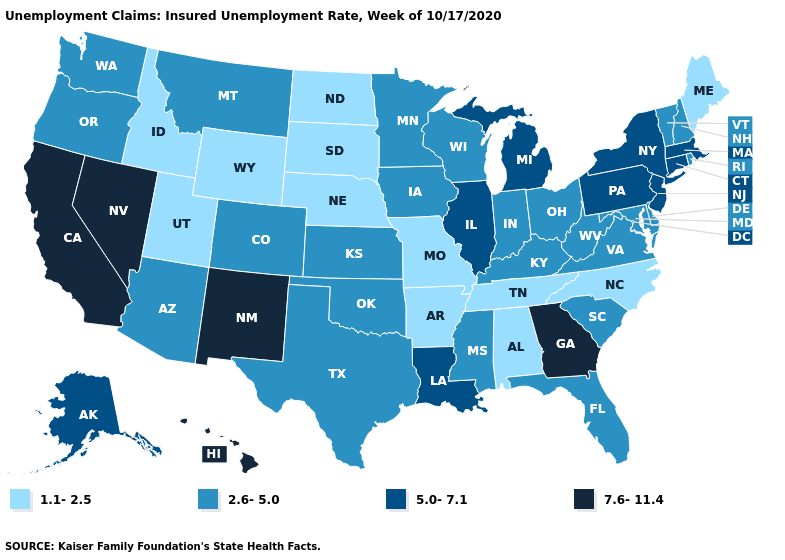What is the value of Maryland?
Write a very short answer. 2.6-5.0. What is the highest value in states that border Colorado?
Quick response, please. 7.6-11.4. What is the value of Wyoming?
Give a very brief answer. 1.1-2.5. Name the states that have a value in the range 2.6-5.0?
Be succinct. Arizona, Colorado, Delaware, Florida, Indiana, Iowa, Kansas, Kentucky, Maryland, Minnesota, Mississippi, Montana, New Hampshire, Ohio, Oklahoma, Oregon, Rhode Island, South Carolina, Texas, Vermont, Virginia, Washington, West Virginia, Wisconsin. Among the states that border Colorado , does Wyoming have the lowest value?
Answer briefly. Yes. What is the value of New Mexico?
Be succinct. 7.6-11.4. Does Kentucky have a higher value than Tennessee?
Keep it brief. Yes. Name the states that have a value in the range 2.6-5.0?
Quick response, please. Arizona, Colorado, Delaware, Florida, Indiana, Iowa, Kansas, Kentucky, Maryland, Minnesota, Mississippi, Montana, New Hampshire, Ohio, Oklahoma, Oregon, Rhode Island, South Carolina, Texas, Vermont, Virginia, Washington, West Virginia, Wisconsin. Name the states that have a value in the range 2.6-5.0?
Write a very short answer. Arizona, Colorado, Delaware, Florida, Indiana, Iowa, Kansas, Kentucky, Maryland, Minnesota, Mississippi, Montana, New Hampshire, Ohio, Oklahoma, Oregon, Rhode Island, South Carolina, Texas, Vermont, Virginia, Washington, West Virginia, Wisconsin. Does Michigan have a higher value than Georgia?
Short answer required. No. What is the lowest value in states that border South Dakota?
Short answer required. 1.1-2.5. What is the lowest value in the South?
Be succinct. 1.1-2.5. What is the highest value in states that border Pennsylvania?
Answer briefly. 5.0-7.1. What is the value of New Jersey?
Short answer required. 5.0-7.1. Name the states that have a value in the range 2.6-5.0?
Be succinct. Arizona, Colorado, Delaware, Florida, Indiana, Iowa, Kansas, Kentucky, Maryland, Minnesota, Mississippi, Montana, New Hampshire, Ohio, Oklahoma, Oregon, Rhode Island, South Carolina, Texas, Vermont, Virginia, Washington, West Virginia, Wisconsin. 